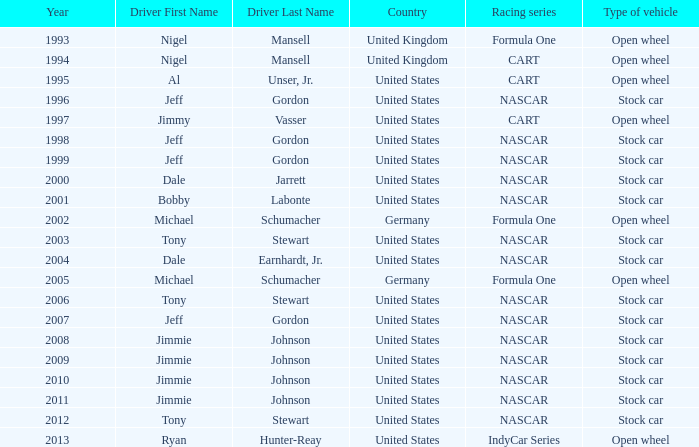Could you help me parse every detail presented in this table? {'header': ['Year', 'Driver First Name', 'Driver Last Name', 'Country', 'Racing series', 'Type of vehicle'], 'rows': [['1993', 'Nigel', 'Mansell', 'United Kingdom', 'Formula One', 'Open wheel'], ['1994', 'Nigel', 'Mansell', 'United Kingdom', 'CART', 'Open wheel'], ['1995', 'Al', 'Unser, Jr.', 'United States', 'CART', 'Open wheel'], ['1996', 'Jeff', 'Gordon', 'United States', 'NASCAR', 'Stock car'], ['1997', 'Jimmy', 'Vasser', 'United States', 'CART', 'Open wheel'], ['1998', 'Jeff', 'Gordon', 'United States', 'NASCAR', 'Stock car'], ['1999', 'Jeff', 'Gordon', 'United States', 'NASCAR', 'Stock car'], ['2000', 'Dale', 'Jarrett', 'United States', 'NASCAR', 'Stock car'], ['2001', 'Bobby', 'Labonte', 'United States', 'NASCAR', 'Stock car'], ['2002', 'Michael', 'Schumacher', 'Germany', 'Formula One', 'Open wheel'], ['2003', 'Tony', 'Stewart', 'United States', 'NASCAR', 'Stock car'], ['2004', 'Dale', 'Earnhardt, Jr.', 'United States', 'NASCAR', 'Stock car'], ['2005', 'Michael', 'Schumacher', 'Germany', 'Formula One', 'Open wheel'], ['2006', 'Tony', 'Stewart', 'United States', 'NASCAR', 'Stock car'], ['2007', 'Jeff', 'Gordon', 'United States', 'NASCAR', 'Stock car'], ['2008', 'Jimmie', 'Johnson', 'United States', 'NASCAR', 'Stock car'], ['2009', 'Jimmie', 'Johnson', 'United States', 'NASCAR', 'Stock car'], ['2010', 'Jimmie', 'Johnson', 'United States', 'NASCAR', 'Stock car'], ['2011', 'Jimmie', 'Johnson', 'United States', 'NASCAR', 'Stock car'], ['2012', 'Tony', 'Stewart', 'United States', 'NASCAR', 'Stock car'], ['2013', 'Ryan', 'Hunter-Reay', 'United States', 'IndyCar Series', 'Open wheel']]} Which country's citizenship is associated with a stock car from the year 2012? United States. 